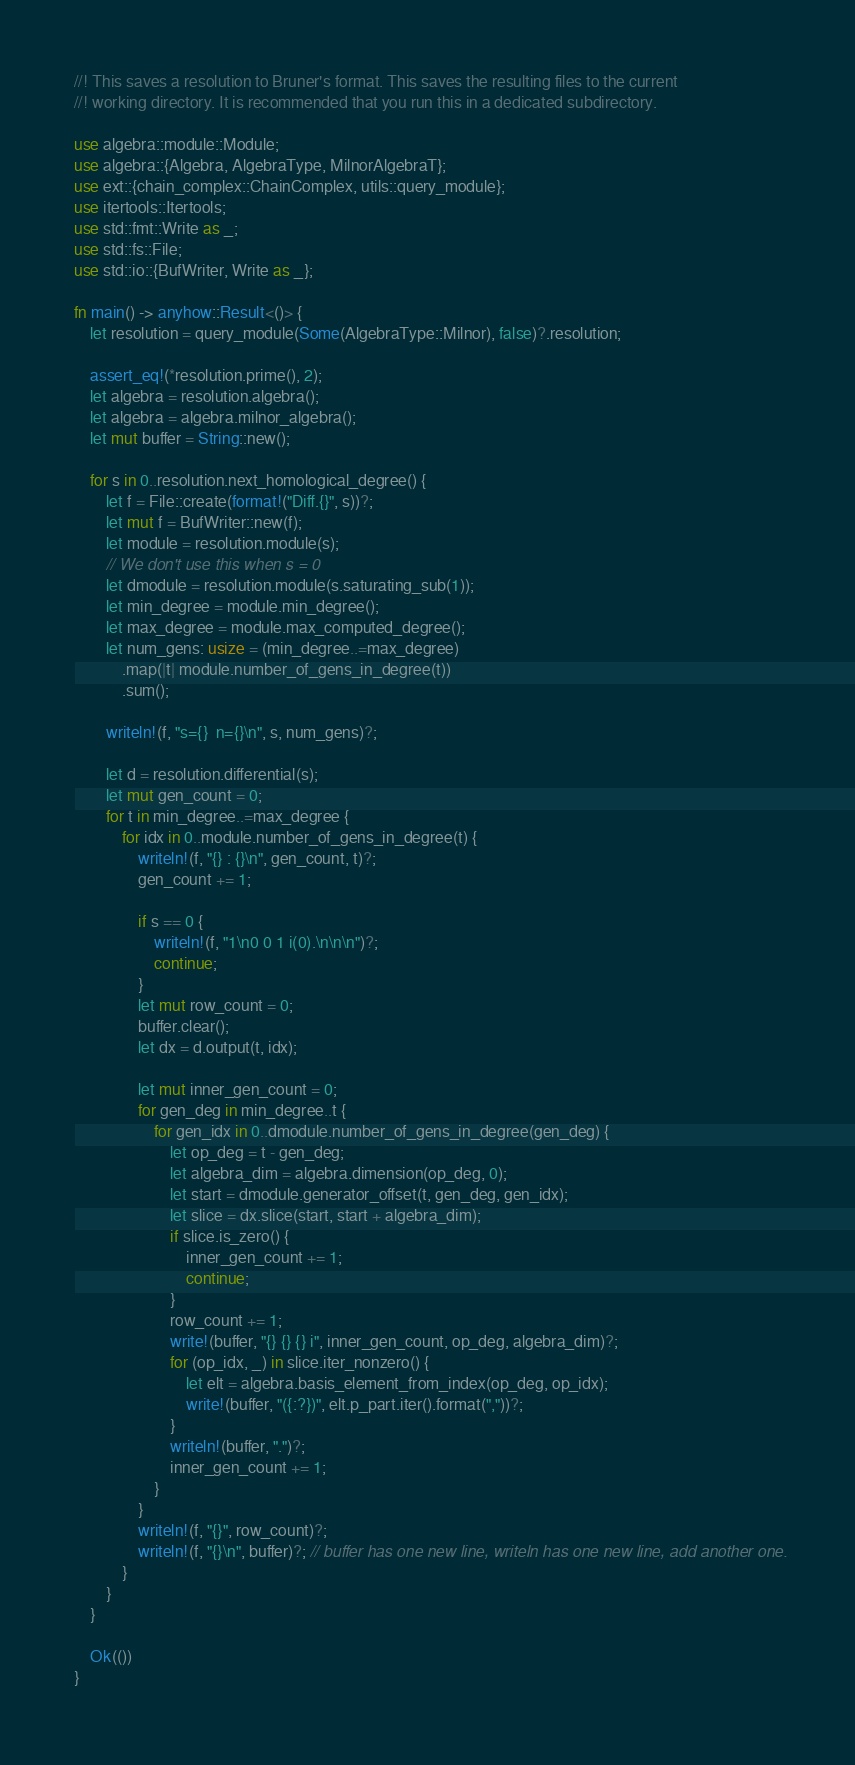<code> <loc_0><loc_0><loc_500><loc_500><_Rust_>//! This saves a resolution to Bruner's format. This saves the resulting files to the current
//! working directory. It is recommended that you run this in a dedicated subdirectory.

use algebra::module::Module;
use algebra::{Algebra, AlgebraType, MilnorAlgebraT};
use ext::{chain_complex::ChainComplex, utils::query_module};
use itertools::Itertools;
use std::fmt::Write as _;
use std::fs::File;
use std::io::{BufWriter, Write as _};

fn main() -> anyhow::Result<()> {
    let resolution = query_module(Some(AlgebraType::Milnor), false)?.resolution;

    assert_eq!(*resolution.prime(), 2);
    let algebra = resolution.algebra();
    let algebra = algebra.milnor_algebra();
    let mut buffer = String::new();

    for s in 0..resolution.next_homological_degree() {
        let f = File::create(format!("Diff.{}", s))?;
        let mut f = BufWriter::new(f);
        let module = resolution.module(s);
        // We don't use this when s = 0
        let dmodule = resolution.module(s.saturating_sub(1));
        let min_degree = module.min_degree();
        let max_degree = module.max_computed_degree();
        let num_gens: usize = (min_degree..=max_degree)
            .map(|t| module.number_of_gens_in_degree(t))
            .sum();

        writeln!(f, "s={}  n={}\n", s, num_gens)?;

        let d = resolution.differential(s);
        let mut gen_count = 0;
        for t in min_degree..=max_degree {
            for idx in 0..module.number_of_gens_in_degree(t) {
                writeln!(f, "{} : {}\n", gen_count, t)?;
                gen_count += 1;

                if s == 0 {
                    writeln!(f, "1\n0 0 1 i(0).\n\n\n")?;
                    continue;
                }
                let mut row_count = 0;
                buffer.clear();
                let dx = d.output(t, idx);

                let mut inner_gen_count = 0;
                for gen_deg in min_degree..t {
                    for gen_idx in 0..dmodule.number_of_gens_in_degree(gen_deg) {
                        let op_deg = t - gen_deg;
                        let algebra_dim = algebra.dimension(op_deg, 0);
                        let start = dmodule.generator_offset(t, gen_deg, gen_idx);
                        let slice = dx.slice(start, start + algebra_dim);
                        if slice.is_zero() {
                            inner_gen_count += 1;
                            continue;
                        }
                        row_count += 1;
                        write!(buffer, "{} {} {} i", inner_gen_count, op_deg, algebra_dim)?;
                        for (op_idx, _) in slice.iter_nonzero() {
                            let elt = algebra.basis_element_from_index(op_deg, op_idx);
                            write!(buffer, "({:?})", elt.p_part.iter().format(","))?;
                        }
                        writeln!(buffer, ".")?;
                        inner_gen_count += 1;
                    }
                }
                writeln!(f, "{}", row_count)?;
                writeln!(f, "{}\n", buffer)?; // buffer has one new line, writeln has one new line, add another one.
            }
        }
    }

    Ok(())
}
</code> 